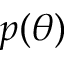<formula> <loc_0><loc_0><loc_500><loc_500>p ( \theta )</formula> 